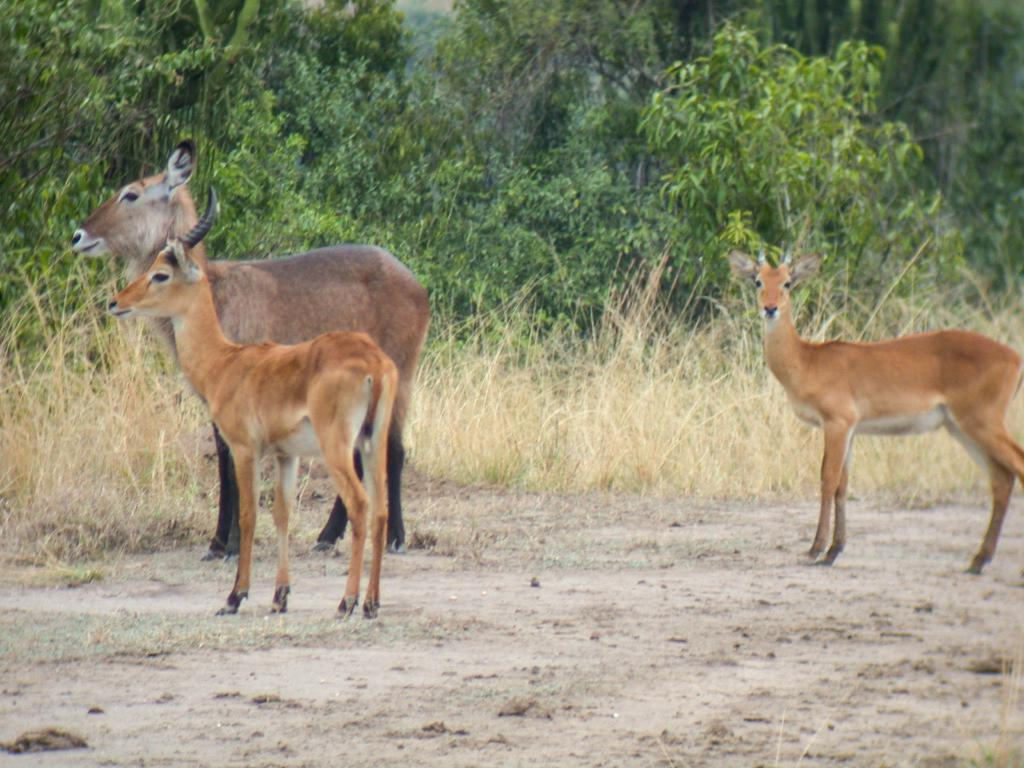How many deer are present in the image? There are three deer in the image. What is the position of the deer in the image? The deer are standing on the ground. What can be seen in the background of the image? There are trees in the background of the image. What type of terrain is visible at the bottom of the image? There is sand at the bottom of the image. What type of vegetation is present beside the sand? There is grass beside the sand. What type of stocking is the deer wearing on its leg in the image? There are no stockings visible on the deer in the image; they are not wearing any clothing. 